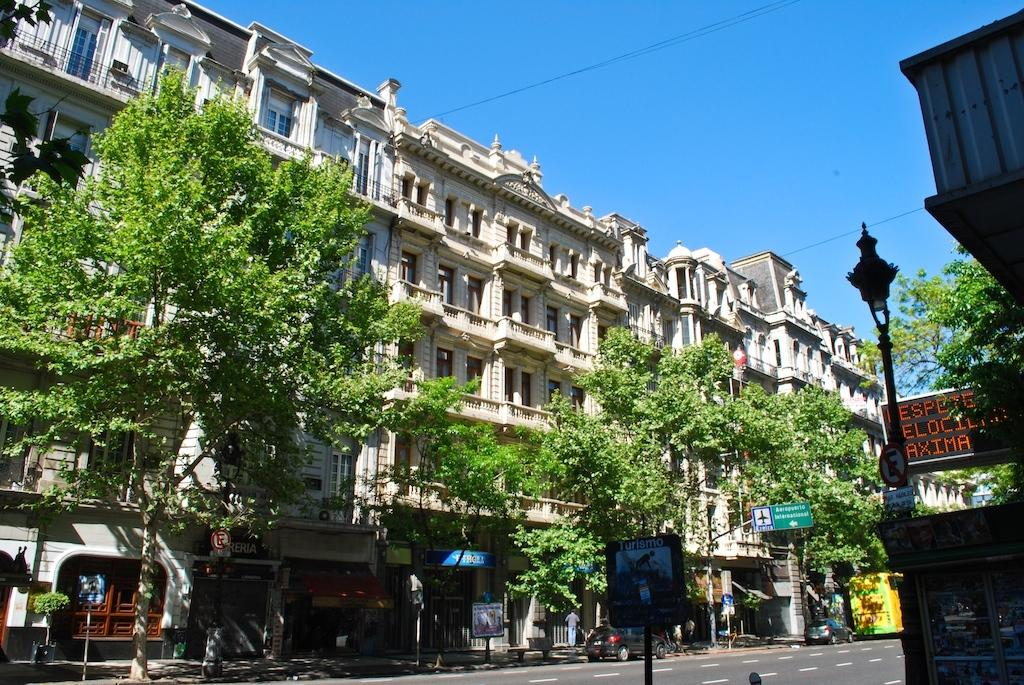How many people can be seen in the image? There are people in the image. What is the primary feature of the landscape in the image? There is a road in the image. What types of vehicles are present in the image? There are vehicles in the image. What structures can be seen supporting something in the image? There are poles in the image. What type of illumination is present in the image? There are lights in the image. What type of signage is present in the image? There are boards in the image. What type of display devices are present in the image? There are screens in the image. What type of buildings can be seen in the image? There are buildings with windows in the image. What type of vegetation is present in the image? There are trees in the image. What part of the natural environment is visible in the image? The sky is visible in the image. How many women are sitting on the beam in the image? There is no beam present in the image, and therefore no women can be seen sitting on it. What type of wall is visible in the image? There is no wall visible in the image. 